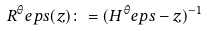<formula> <loc_0><loc_0><loc_500><loc_500>R ^ { \theta } _ { \ } e p s ( z ) \colon = ( H ^ { \theta } _ { \ } e p s - z ) ^ { - 1 }</formula> 